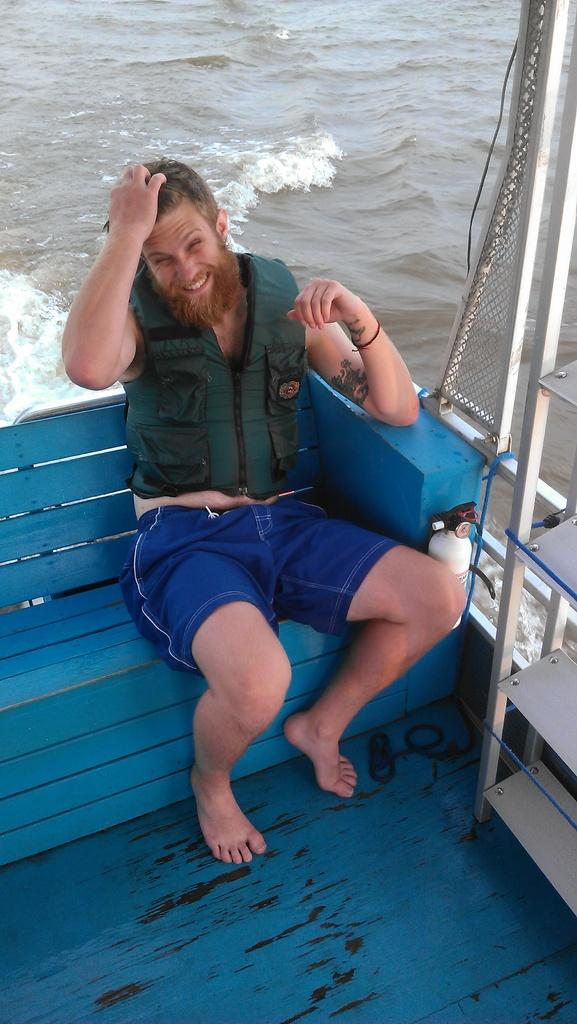What is the person in the image doing? The person is sitting on a bench in the image. What is the person wearing? The person is wearing a green and blue color dress. What color is the bench the person is sitting on? The bench is blue. What can be seen in the background of the image? There is water visible in the background of the image. What type of drug is the person holding in the image? There is no drug present in the image; the person is simply sitting on a bench. How many knots are tied on the person's dress in the image? The person's dress does not have any knots; it is a solid green and blue color. 